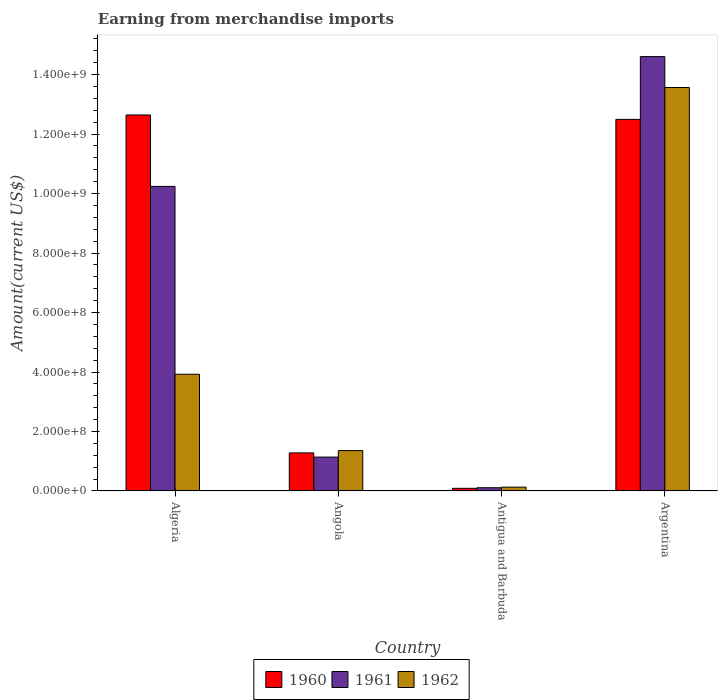How many different coloured bars are there?
Give a very brief answer. 3. Are the number of bars per tick equal to the number of legend labels?
Offer a terse response. Yes. Are the number of bars on each tick of the X-axis equal?
Your response must be concise. Yes. How many bars are there on the 1st tick from the left?
Provide a succinct answer. 3. How many bars are there on the 3rd tick from the right?
Your response must be concise. 3. What is the label of the 3rd group of bars from the left?
Provide a short and direct response. Antigua and Barbuda. What is the amount earned from merchandise imports in 1960 in Antigua and Barbuda?
Your answer should be compact. 9.00e+06. Across all countries, what is the maximum amount earned from merchandise imports in 1960?
Offer a very short reply. 1.26e+09. Across all countries, what is the minimum amount earned from merchandise imports in 1961?
Make the answer very short. 1.10e+07. In which country was the amount earned from merchandise imports in 1962 minimum?
Provide a succinct answer. Antigua and Barbuda. What is the total amount earned from merchandise imports in 1961 in the graph?
Make the answer very short. 2.61e+09. What is the difference between the amount earned from merchandise imports in 1961 in Algeria and that in Angola?
Keep it short and to the point. 9.10e+08. What is the difference between the amount earned from merchandise imports in 1960 in Antigua and Barbuda and the amount earned from merchandise imports in 1961 in Angola?
Offer a very short reply. -1.05e+08. What is the average amount earned from merchandise imports in 1962 per country?
Give a very brief answer. 4.75e+08. What is the difference between the amount earned from merchandise imports of/in 1960 and amount earned from merchandise imports of/in 1962 in Algeria?
Your response must be concise. 8.72e+08. In how many countries, is the amount earned from merchandise imports in 1960 greater than 1120000000 US$?
Offer a very short reply. 2. What is the ratio of the amount earned from merchandise imports in 1961 in Angola to that in Antigua and Barbuda?
Your response must be concise. 10.36. What is the difference between the highest and the second highest amount earned from merchandise imports in 1961?
Ensure brevity in your answer.  4.37e+08. What is the difference between the highest and the lowest amount earned from merchandise imports in 1960?
Offer a terse response. 1.26e+09. In how many countries, is the amount earned from merchandise imports in 1962 greater than the average amount earned from merchandise imports in 1962 taken over all countries?
Make the answer very short. 1. What does the 1st bar from the left in Antigua and Barbuda represents?
Offer a terse response. 1960. Is it the case that in every country, the sum of the amount earned from merchandise imports in 1960 and amount earned from merchandise imports in 1961 is greater than the amount earned from merchandise imports in 1962?
Offer a very short reply. Yes. How many bars are there?
Your response must be concise. 12. Does the graph contain any zero values?
Offer a very short reply. No. Does the graph contain grids?
Provide a short and direct response. No. Where does the legend appear in the graph?
Offer a terse response. Bottom center. How many legend labels are there?
Your response must be concise. 3. What is the title of the graph?
Make the answer very short. Earning from merchandise imports. Does "1980" appear as one of the legend labels in the graph?
Your response must be concise. No. What is the label or title of the Y-axis?
Make the answer very short. Amount(current US$). What is the Amount(current US$) in 1960 in Algeria?
Make the answer very short. 1.26e+09. What is the Amount(current US$) of 1961 in Algeria?
Keep it short and to the point. 1.02e+09. What is the Amount(current US$) in 1962 in Algeria?
Your answer should be compact. 3.93e+08. What is the Amount(current US$) of 1960 in Angola?
Provide a short and direct response. 1.28e+08. What is the Amount(current US$) in 1961 in Angola?
Your answer should be very brief. 1.14e+08. What is the Amount(current US$) in 1962 in Angola?
Your answer should be very brief. 1.36e+08. What is the Amount(current US$) of 1960 in Antigua and Barbuda?
Provide a short and direct response. 9.00e+06. What is the Amount(current US$) in 1961 in Antigua and Barbuda?
Give a very brief answer. 1.10e+07. What is the Amount(current US$) of 1962 in Antigua and Barbuda?
Make the answer very short. 1.30e+07. What is the Amount(current US$) in 1960 in Argentina?
Offer a terse response. 1.25e+09. What is the Amount(current US$) in 1961 in Argentina?
Offer a terse response. 1.46e+09. What is the Amount(current US$) of 1962 in Argentina?
Provide a succinct answer. 1.36e+09. Across all countries, what is the maximum Amount(current US$) in 1960?
Ensure brevity in your answer.  1.26e+09. Across all countries, what is the maximum Amount(current US$) of 1961?
Provide a short and direct response. 1.46e+09. Across all countries, what is the maximum Amount(current US$) of 1962?
Ensure brevity in your answer.  1.36e+09. Across all countries, what is the minimum Amount(current US$) in 1960?
Make the answer very short. 9.00e+06. Across all countries, what is the minimum Amount(current US$) in 1961?
Offer a very short reply. 1.10e+07. Across all countries, what is the minimum Amount(current US$) of 1962?
Offer a very short reply. 1.30e+07. What is the total Amount(current US$) of 1960 in the graph?
Offer a terse response. 2.65e+09. What is the total Amount(current US$) in 1961 in the graph?
Give a very brief answer. 2.61e+09. What is the total Amount(current US$) in 1962 in the graph?
Ensure brevity in your answer.  1.90e+09. What is the difference between the Amount(current US$) in 1960 in Algeria and that in Angola?
Provide a short and direct response. 1.14e+09. What is the difference between the Amount(current US$) of 1961 in Algeria and that in Angola?
Offer a terse response. 9.10e+08. What is the difference between the Amount(current US$) of 1962 in Algeria and that in Angola?
Offer a very short reply. 2.57e+08. What is the difference between the Amount(current US$) of 1960 in Algeria and that in Antigua and Barbuda?
Your answer should be very brief. 1.26e+09. What is the difference between the Amount(current US$) in 1961 in Algeria and that in Antigua and Barbuda?
Your response must be concise. 1.01e+09. What is the difference between the Amount(current US$) of 1962 in Algeria and that in Antigua and Barbuda?
Your answer should be compact. 3.80e+08. What is the difference between the Amount(current US$) in 1960 in Algeria and that in Argentina?
Provide a short and direct response. 1.48e+07. What is the difference between the Amount(current US$) of 1961 in Algeria and that in Argentina?
Your answer should be compact. -4.37e+08. What is the difference between the Amount(current US$) in 1962 in Algeria and that in Argentina?
Your response must be concise. -9.64e+08. What is the difference between the Amount(current US$) of 1960 in Angola and that in Antigua and Barbuda?
Provide a succinct answer. 1.19e+08. What is the difference between the Amount(current US$) in 1961 in Angola and that in Antigua and Barbuda?
Your answer should be very brief. 1.03e+08. What is the difference between the Amount(current US$) of 1962 in Angola and that in Antigua and Barbuda?
Your response must be concise. 1.23e+08. What is the difference between the Amount(current US$) of 1960 in Angola and that in Argentina?
Your answer should be very brief. -1.12e+09. What is the difference between the Amount(current US$) of 1961 in Angola and that in Argentina?
Provide a short and direct response. -1.35e+09. What is the difference between the Amount(current US$) of 1962 in Angola and that in Argentina?
Your answer should be compact. -1.22e+09. What is the difference between the Amount(current US$) of 1960 in Antigua and Barbuda and that in Argentina?
Keep it short and to the point. -1.24e+09. What is the difference between the Amount(current US$) in 1961 in Antigua and Barbuda and that in Argentina?
Your answer should be very brief. -1.45e+09. What is the difference between the Amount(current US$) of 1962 in Antigua and Barbuda and that in Argentina?
Your response must be concise. -1.34e+09. What is the difference between the Amount(current US$) of 1960 in Algeria and the Amount(current US$) of 1961 in Angola?
Provide a succinct answer. 1.15e+09. What is the difference between the Amount(current US$) of 1960 in Algeria and the Amount(current US$) of 1962 in Angola?
Provide a succinct answer. 1.13e+09. What is the difference between the Amount(current US$) in 1961 in Algeria and the Amount(current US$) in 1962 in Angola?
Offer a very short reply. 8.88e+08. What is the difference between the Amount(current US$) in 1960 in Algeria and the Amount(current US$) in 1961 in Antigua and Barbuda?
Provide a succinct answer. 1.25e+09. What is the difference between the Amount(current US$) of 1960 in Algeria and the Amount(current US$) of 1962 in Antigua and Barbuda?
Your answer should be compact. 1.25e+09. What is the difference between the Amount(current US$) in 1961 in Algeria and the Amount(current US$) in 1962 in Antigua and Barbuda?
Offer a terse response. 1.01e+09. What is the difference between the Amount(current US$) of 1960 in Algeria and the Amount(current US$) of 1961 in Argentina?
Your answer should be very brief. -1.96e+08. What is the difference between the Amount(current US$) of 1960 in Algeria and the Amount(current US$) of 1962 in Argentina?
Keep it short and to the point. -9.24e+07. What is the difference between the Amount(current US$) in 1961 in Algeria and the Amount(current US$) in 1962 in Argentina?
Your answer should be very brief. -3.33e+08. What is the difference between the Amount(current US$) of 1960 in Angola and the Amount(current US$) of 1961 in Antigua and Barbuda?
Offer a very short reply. 1.17e+08. What is the difference between the Amount(current US$) in 1960 in Angola and the Amount(current US$) in 1962 in Antigua and Barbuda?
Keep it short and to the point. 1.15e+08. What is the difference between the Amount(current US$) of 1961 in Angola and the Amount(current US$) of 1962 in Antigua and Barbuda?
Give a very brief answer. 1.01e+08. What is the difference between the Amount(current US$) in 1960 in Angola and the Amount(current US$) in 1961 in Argentina?
Offer a very short reply. -1.33e+09. What is the difference between the Amount(current US$) of 1960 in Angola and the Amount(current US$) of 1962 in Argentina?
Your answer should be compact. -1.23e+09. What is the difference between the Amount(current US$) of 1961 in Angola and the Amount(current US$) of 1962 in Argentina?
Ensure brevity in your answer.  -1.24e+09. What is the difference between the Amount(current US$) in 1960 in Antigua and Barbuda and the Amount(current US$) in 1961 in Argentina?
Keep it short and to the point. -1.45e+09. What is the difference between the Amount(current US$) in 1960 in Antigua and Barbuda and the Amount(current US$) in 1962 in Argentina?
Your answer should be very brief. -1.35e+09. What is the difference between the Amount(current US$) in 1961 in Antigua and Barbuda and the Amount(current US$) in 1962 in Argentina?
Make the answer very short. -1.35e+09. What is the average Amount(current US$) in 1960 per country?
Provide a succinct answer. 6.63e+08. What is the average Amount(current US$) in 1961 per country?
Make the answer very short. 6.52e+08. What is the average Amount(current US$) in 1962 per country?
Your answer should be compact. 4.75e+08. What is the difference between the Amount(current US$) of 1960 and Amount(current US$) of 1961 in Algeria?
Make the answer very short. 2.40e+08. What is the difference between the Amount(current US$) in 1960 and Amount(current US$) in 1962 in Algeria?
Your response must be concise. 8.72e+08. What is the difference between the Amount(current US$) in 1961 and Amount(current US$) in 1962 in Algeria?
Your answer should be compact. 6.31e+08. What is the difference between the Amount(current US$) of 1960 and Amount(current US$) of 1961 in Angola?
Your answer should be compact. 1.40e+07. What is the difference between the Amount(current US$) in 1960 and Amount(current US$) in 1962 in Angola?
Give a very brief answer. -8.00e+06. What is the difference between the Amount(current US$) of 1961 and Amount(current US$) of 1962 in Angola?
Your answer should be compact. -2.20e+07. What is the difference between the Amount(current US$) in 1960 and Amount(current US$) in 1962 in Antigua and Barbuda?
Ensure brevity in your answer.  -4.00e+06. What is the difference between the Amount(current US$) of 1960 and Amount(current US$) of 1961 in Argentina?
Your response must be concise. -2.11e+08. What is the difference between the Amount(current US$) of 1960 and Amount(current US$) of 1962 in Argentina?
Keep it short and to the point. -1.07e+08. What is the difference between the Amount(current US$) in 1961 and Amount(current US$) in 1962 in Argentina?
Offer a terse response. 1.04e+08. What is the ratio of the Amount(current US$) in 1960 in Algeria to that in Angola?
Make the answer very short. 9.88. What is the ratio of the Amount(current US$) of 1961 in Algeria to that in Angola?
Provide a succinct answer. 8.98. What is the ratio of the Amount(current US$) of 1962 in Algeria to that in Angola?
Offer a very short reply. 2.89. What is the ratio of the Amount(current US$) in 1960 in Algeria to that in Antigua and Barbuda?
Give a very brief answer. 140.46. What is the ratio of the Amount(current US$) of 1961 in Algeria to that in Antigua and Barbuda?
Offer a very short reply. 93.08. What is the ratio of the Amount(current US$) in 1962 in Algeria to that in Antigua and Barbuda?
Your answer should be very brief. 30.2. What is the ratio of the Amount(current US$) in 1960 in Algeria to that in Argentina?
Offer a very short reply. 1.01. What is the ratio of the Amount(current US$) in 1961 in Algeria to that in Argentina?
Make the answer very short. 0.7. What is the ratio of the Amount(current US$) of 1962 in Algeria to that in Argentina?
Your answer should be very brief. 0.29. What is the ratio of the Amount(current US$) of 1960 in Angola to that in Antigua and Barbuda?
Provide a short and direct response. 14.22. What is the ratio of the Amount(current US$) in 1961 in Angola to that in Antigua and Barbuda?
Provide a short and direct response. 10.36. What is the ratio of the Amount(current US$) of 1962 in Angola to that in Antigua and Barbuda?
Your answer should be very brief. 10.46. What is the ratio of the Amount(current US$) in 1960 in Angola to that in Argentina?
Offer a very short reply. 0.1. What is the ratio of the Amount(current US$) of 1961 in Angola to that in Argentina?
Ensure brevity in your answer.  0.08. What is the ratio of the Amount(current US$) in 1962 in Angola to that in Argentina?
Give a very brief answer. 0.1. What is the ratio of the Amount(current US$) in 1960 in Antigua and Barbuda to that in Argentina?
Keep it short and to the point. 0.01. What is the ratio of the Amount(current US$) in 1961 in Antigua and Barbuda to that in Argentina?
Offer a very short reply. 0.01. What is the ratio of the Amount(current US$) in 1962 in Antigua and Barbuda to that in Argentina?
Make the answer very short. 0.01. What is the difference between the highest and the second highest Amount(current US$) in 1960?
Keep it short and to the point. 1.48e+07. What is the difference between the highest and the second highest Amount(current US$) of 1961?
Give a very brief answer. 4.37e+08. What is the difference between the highest and the second highest Amount(current US$) in 1962?
Your response must be concise. 9.64e+08. What is the difference between the highest and the lowest Amount(current US$) of 1960?
Keep it short and to the point. 1.26e+09. What is the difference between the highest and the lowest Amount(current US$) in 1961?
Your answer should be very brief. 1.45e+09. What is the difference between the highest and the lowest Amount(current US$) of 1962?
Give a very brief answer. 1.34e+09. 